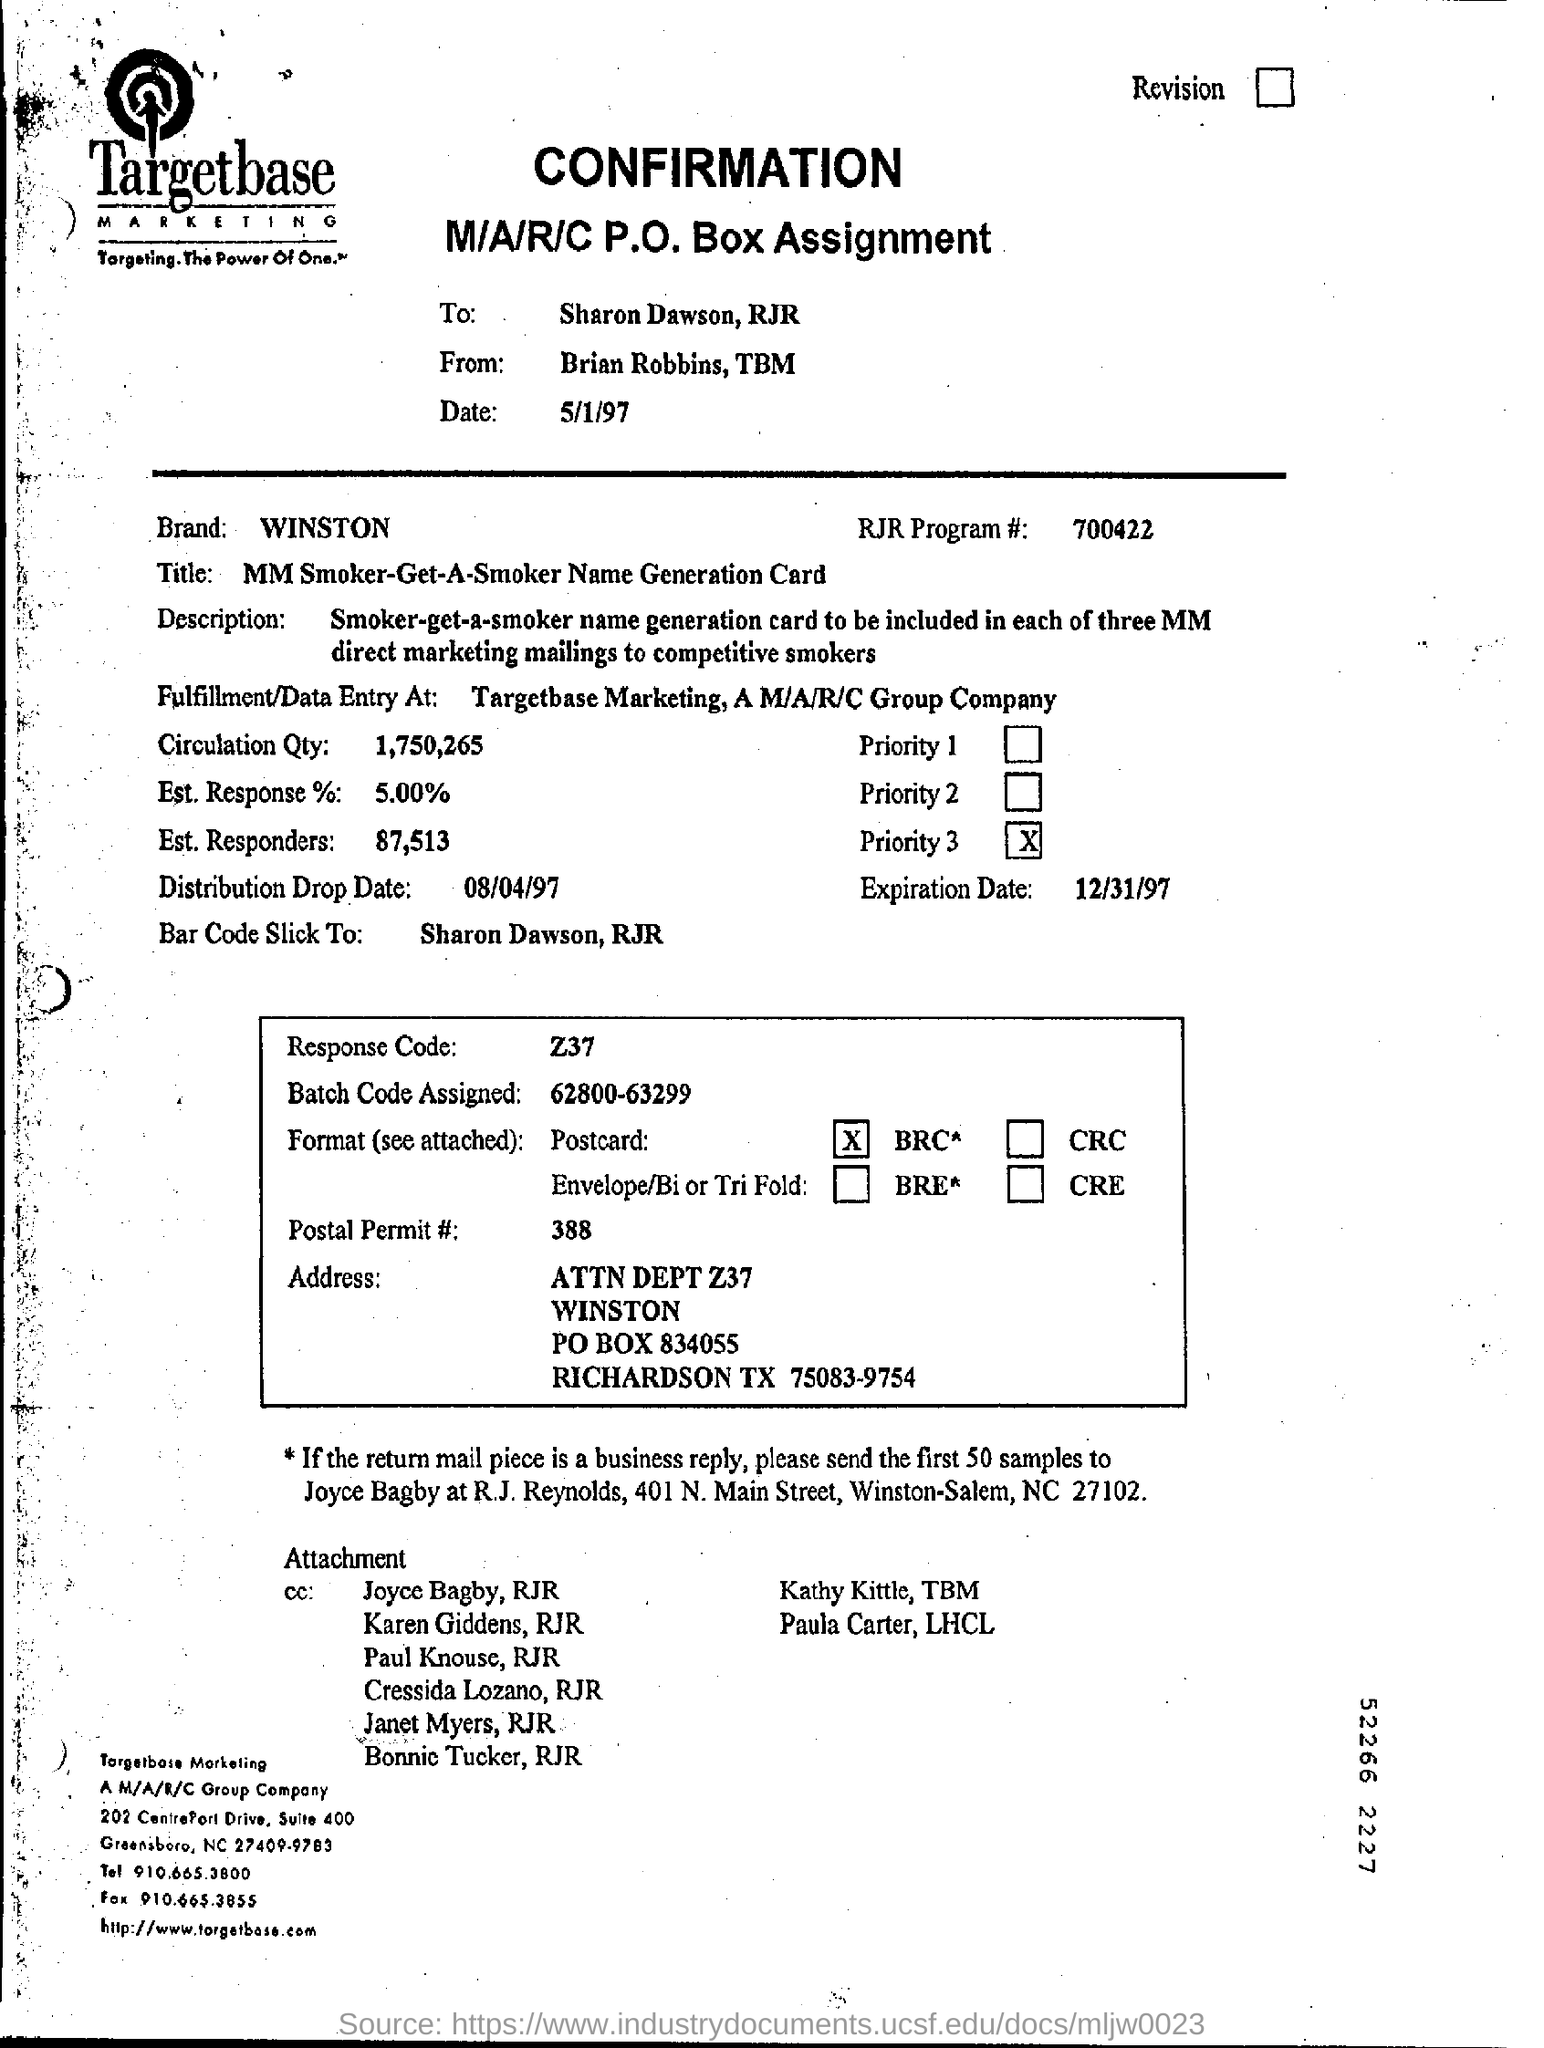Indicate a few pertinent items in this graphic. The date mentioned at the top is May 1, 1997. 